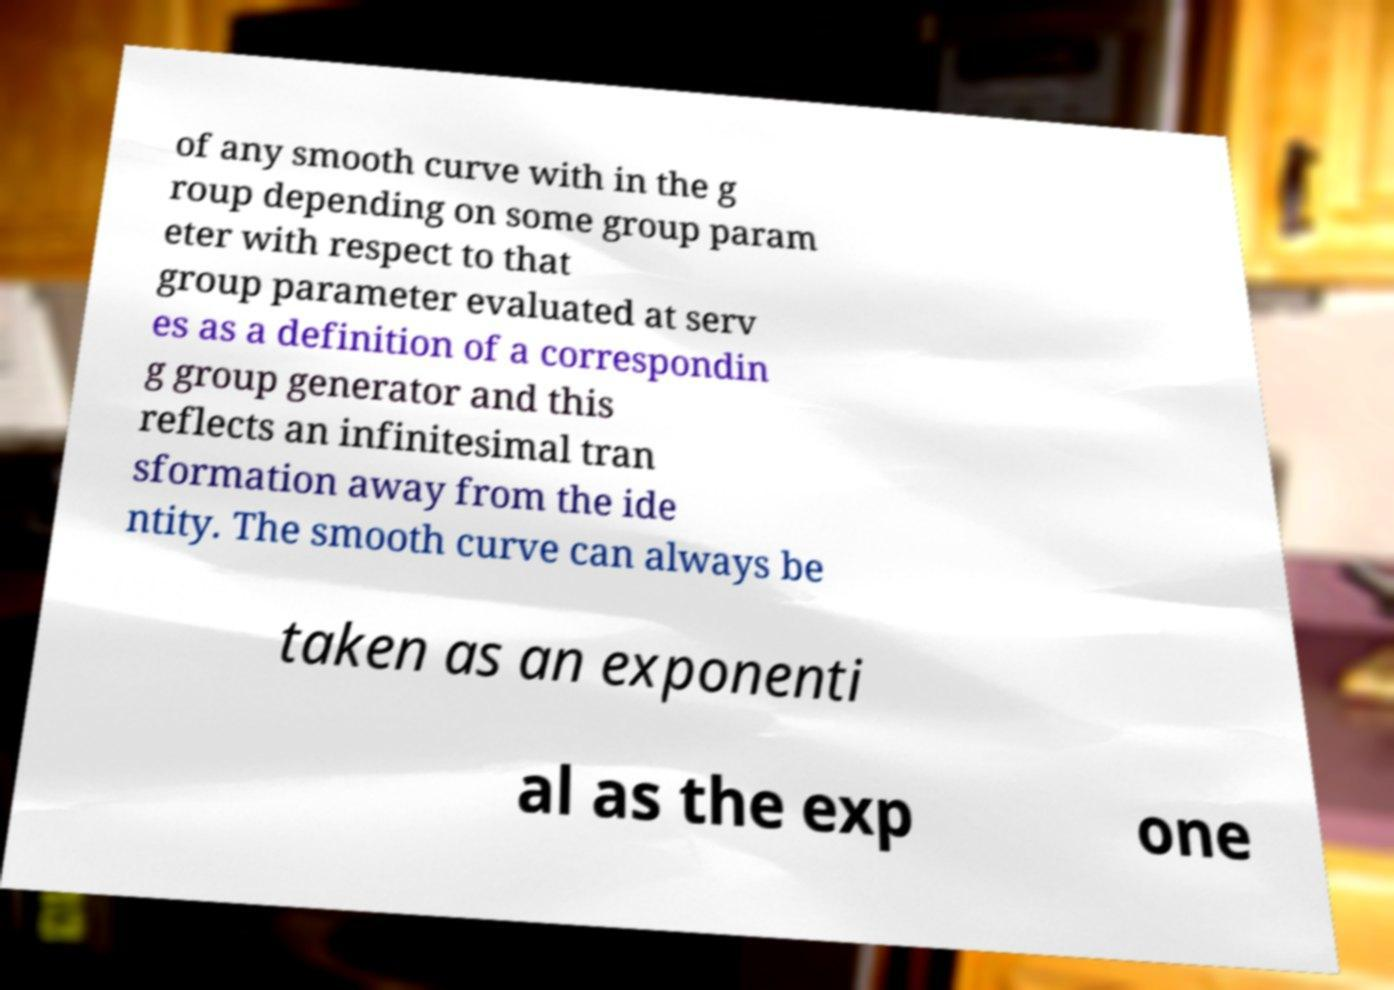There's text embedded in this image that I need extracted. Can you transcribe it verbatim? of any smooth curve with in the g roup depending on some group param eter with respect to that group parameter evaluated at serv es as a definition of a correspondin g group generator and this reflects an infinitesimal tran sformation away from the ide ntity. The smooth curve can always be taken as an exponenti al as the exp one 